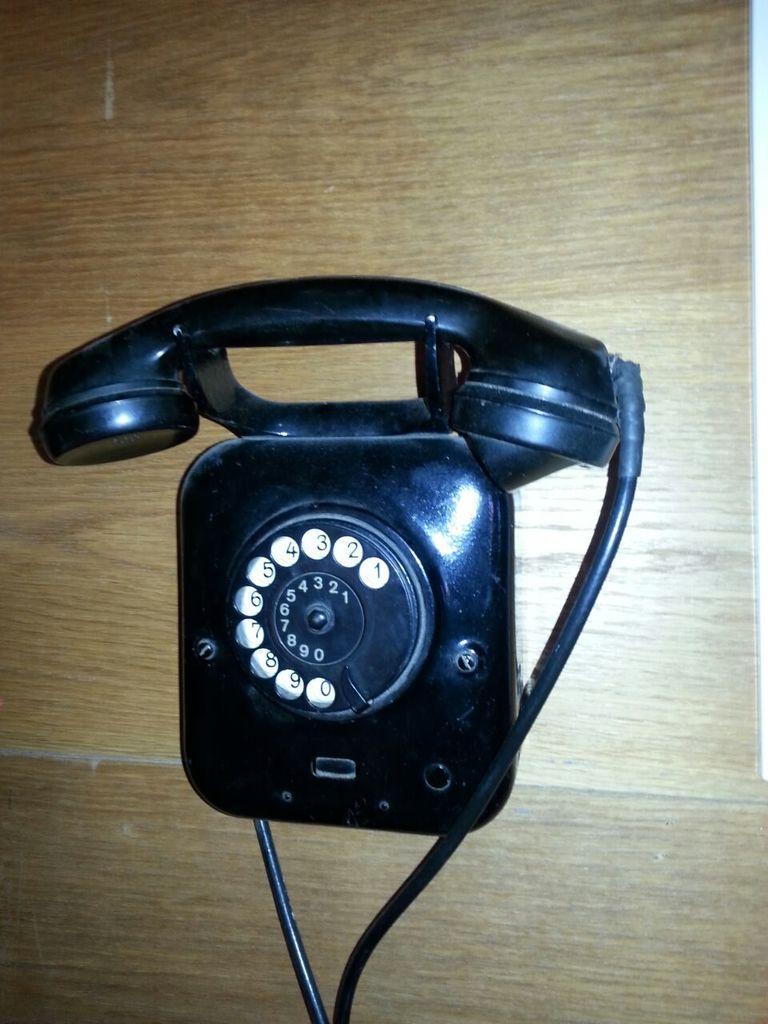Please provide a concise description of this image. Here we can see a landline telephone on a wooden platform. 